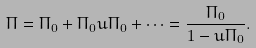<formula> <loc_0><loc_0><loc_500><loc_500>\Pi = \Pi _ { 0 } + \Pi _ { 0 } u \Pi _ { 0 } + \cdots = \frac { \Pi _ { 0 } } { 1 - u \Pi _ { 0 } } .</formula> 